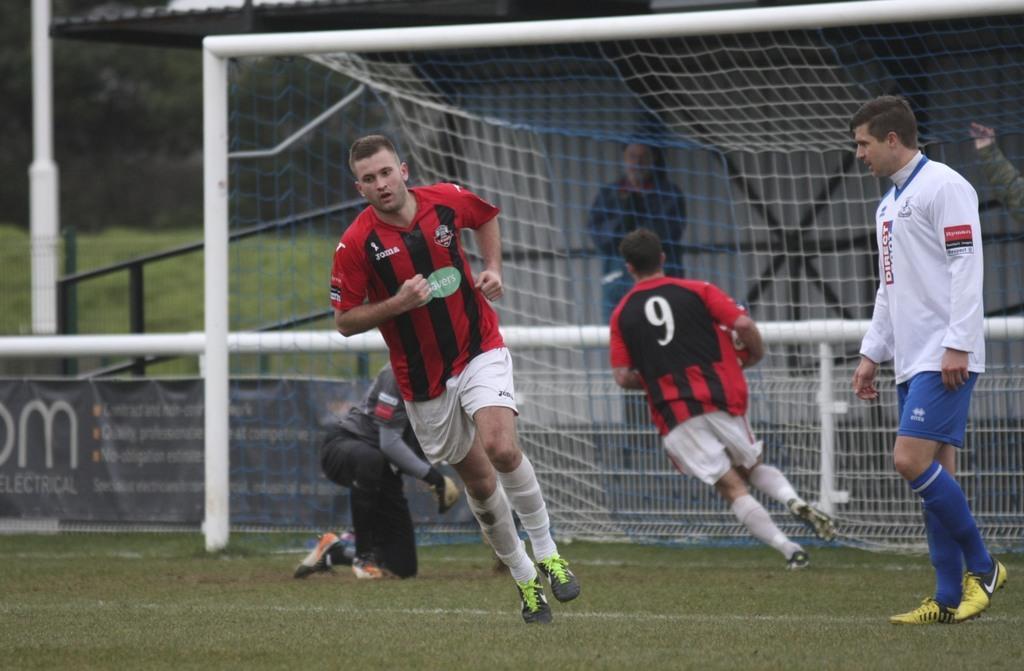Describe this image in one or two sentences. In this image we can see people. There is a goal post. In the background of the image there is a shed. There is a fencing, banner with text. At the bottom of the image there is grass. 